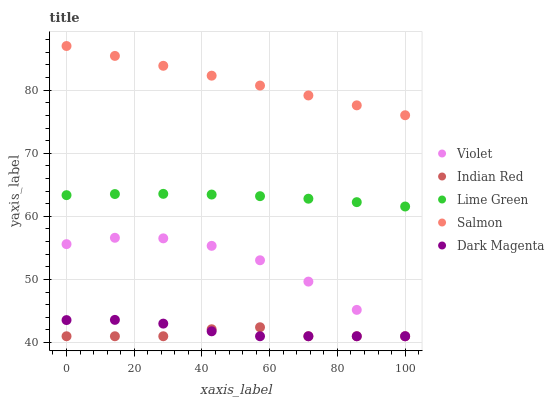Does Indian Red have the minimum area under the curve?
Answer yes or no. Yes. Does Salmon have the maximum area under the curve?
Answer yes or no. Yes. Does Lime Green have the minimum area under the curve?
Answer yes or no. No. Does Lime Green have the maximum area under the curve?
Answer yes or no. No. Is Salmon the smoothest?
Answer yes or no. Yes. Is Violet the roughest?
Answer yes or no. Yes. Is Lime Green the smoothest?
Answer yes or no. No. Is Lime Green the roughest?
Answer yes or no. No. Does Dark Magenta have the lowest value?
Answer yes or no. Yes. Does Lime Green have the lowest value?
Answer yes or no. No. Does Salmon have the highest value?
Answer yes or no. Yes. Does Lime Green have the highest value?
Answer yes or no. No. Is Dark Magenta less than Lime Green?
Answer yes or no. Yes. Is Salmon greater than Indian Red?
Answer yes or no. Yes. Does Dark Magenta intersect Violet?
Answer yes or no. Yes. Is Dark Magenta less than Violet?
Answer yes or no. No. Is Dark Magenta greater than Violet?
Answer yes or no. No. Does Dark Magenta intersect Lime Green?
Answer yes or no. No. 